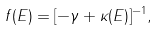Convert formula to latex. <formula><loc_0><loc_0><loc_500><loc_500>f ( E ) = [ - \gamma + \kappa ( E ) ] ^ { - 1 } ,</formula> 